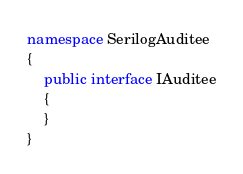Convert code to text. <code><loc_0><loc_0><loc_500><loc_500><_C#_>namespace SerilogAuditee
{
    public interface IAuditee
    {
    }
}
</code> 